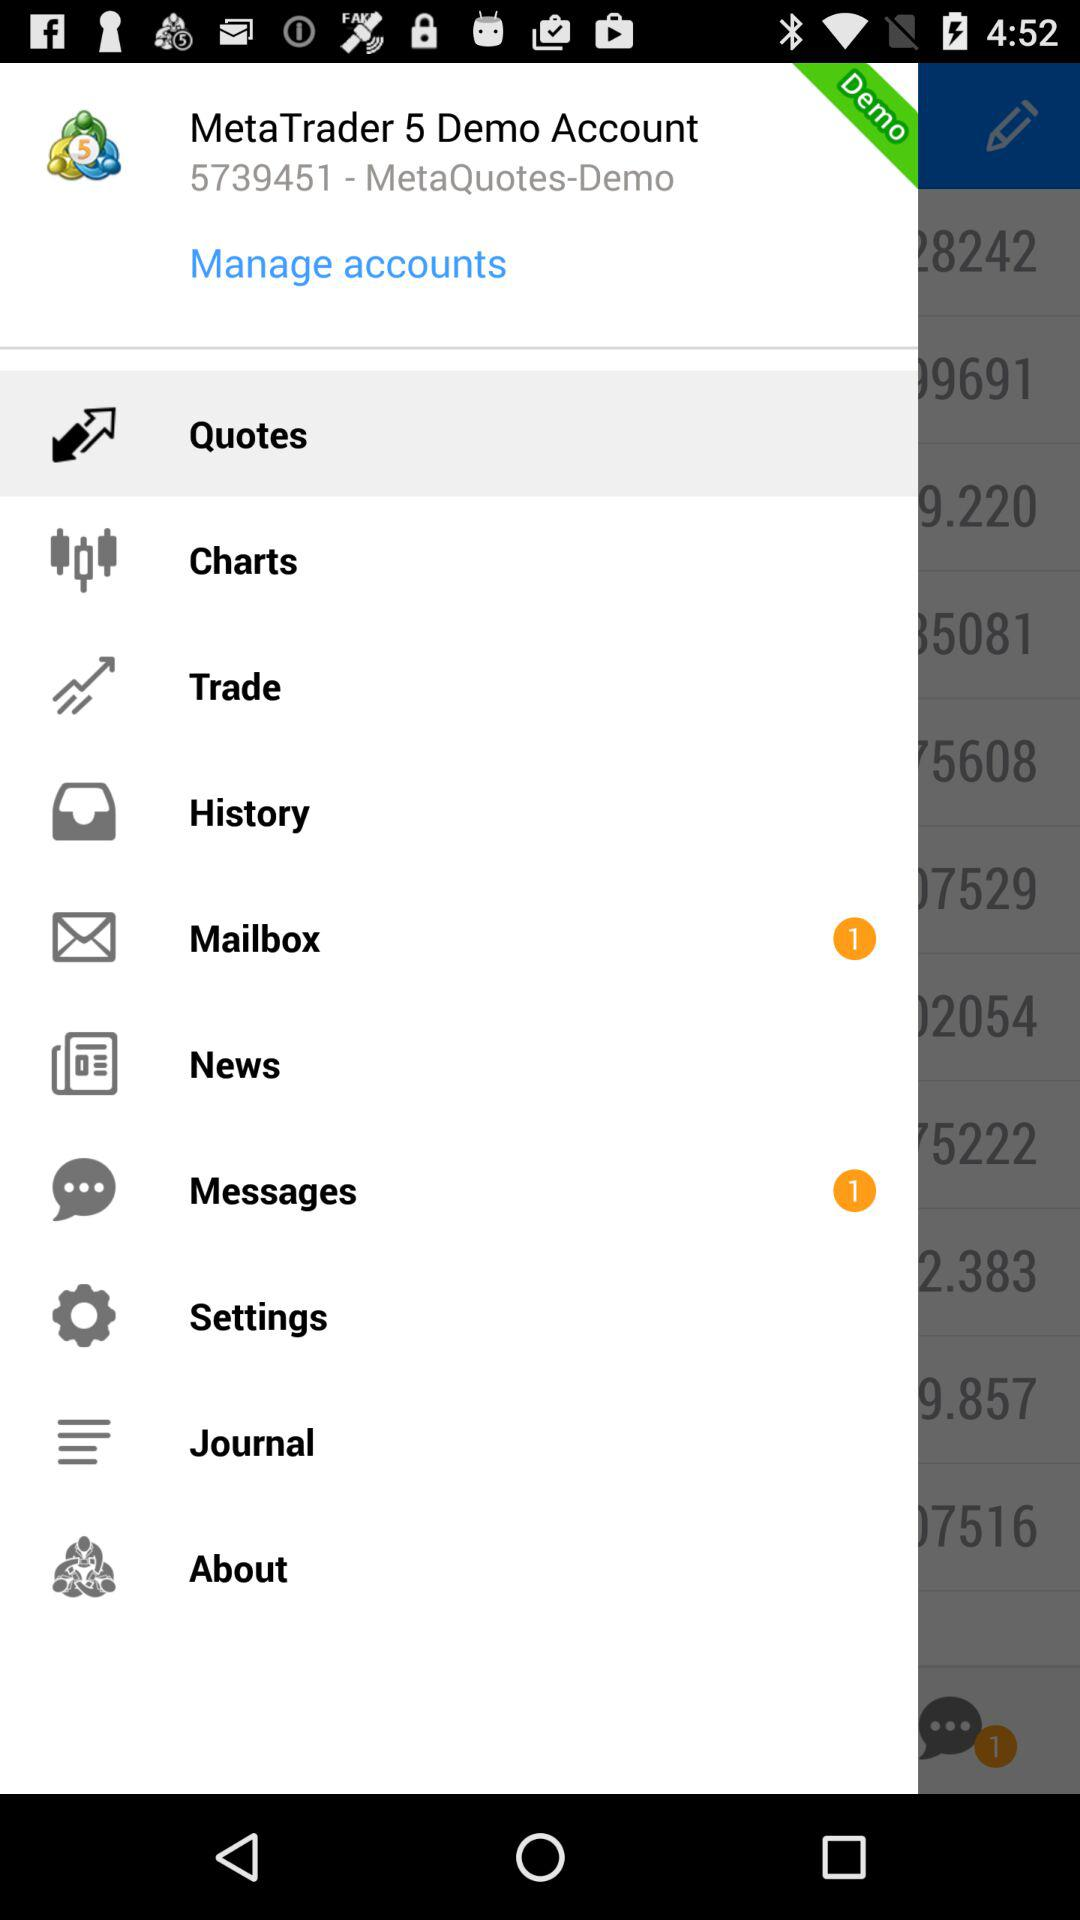How many unread messages are there? There is 1 unread message. 